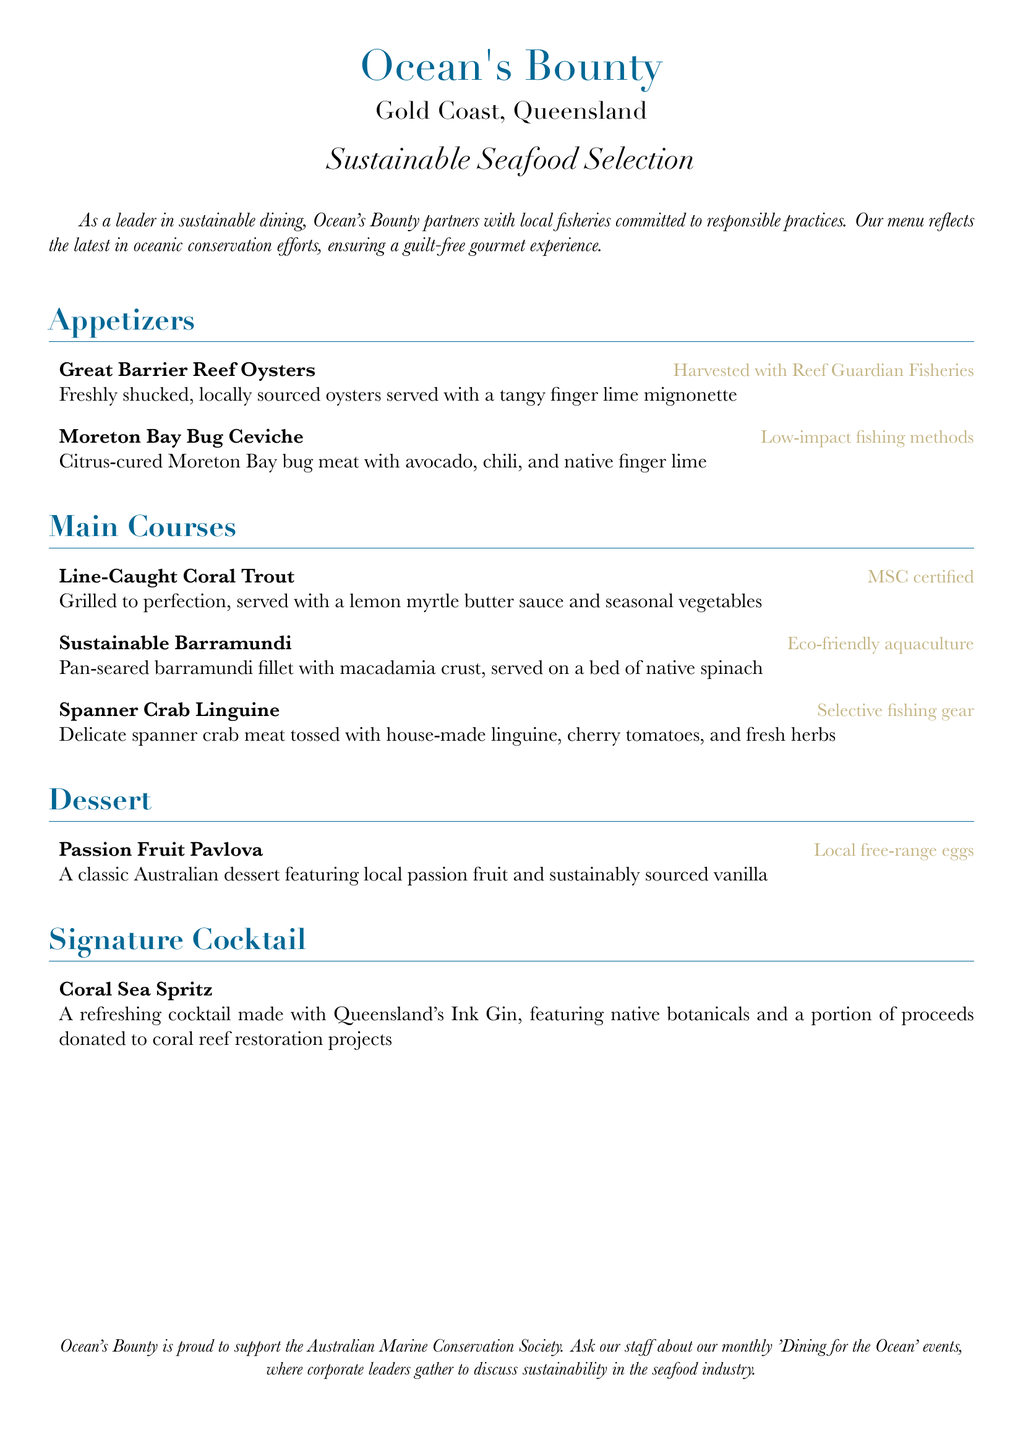What is the name of the restaurant? The restaurant's name is prominently displayed at the top of the menu.
Answer: Ocean's Bounty Where is the restaurant located? The location of the restaurant is mentioned under the name.
Answer: Gold Coast, Queensland What is the focus of the restaurant menu? The focus of the menu is clearly stated in the introduction.
Answer: Sustainable Seafood Selection What type of fishing method is used for Great Barrier Reef Oysters? This information is provided next to the dish in the menu.
Answer: Reef Guardian Fisheries What is the signature cocktail on the menu? The signature cocktail is listed as a separate item in the drink section.
Answer: Coral Sea Spritz What is included in the Moreton Bay Bug Ceviche? The ingredients of the ceviche are described directly under the dish name.
Answer: Avocado, chili, and native finger lime What is the cooking method for Sustainable Barramundi? The cooking method is specified alongside the dish description.
Answer: Pan-seared How does the restaurant support ocean conservation? This information is presented in the last section of the menu.
Answer: Donations to coral reef restoration projects What type of eggs are used in the Passion Fruit Pavlova? The type of eggs is mentioned next to the dessert.
Answer: Local free-range eggs 